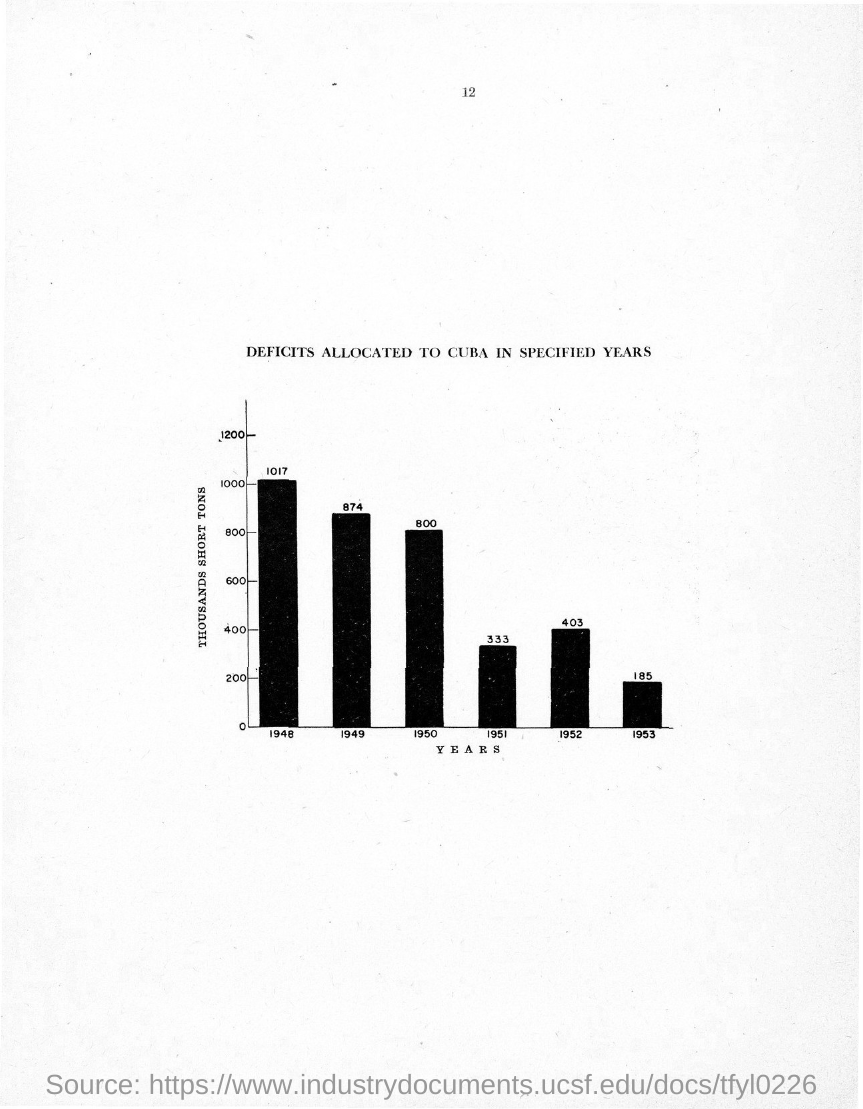Highlight a few significant elements in this photo. The page number mentioned in this document is 12. The title of the graph showing allocations of deficits to Cuba in specified years is [DEFICITS ALLOCATED TO CUBA IN SPECIFIED YEARS]. The x-axis of the graph represents the years. The y-axis of the graph represents thousands of short tons. 